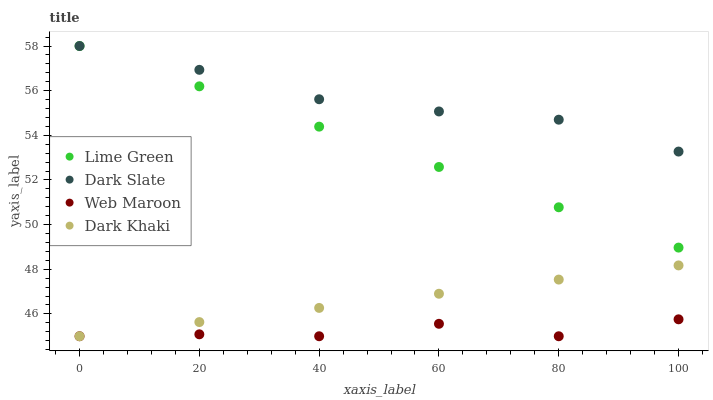Does Web Maroon have the minimum area under the curve?
Answer yes or no. Yes. Does Dark Slate have the maximum area under the curve?
Answer yes or no. Yes. Does Lime Green have the minimum area under the curve?
Answer yes or no. No. Does Lime Green have the maximum area under the curve?
Answer yes or no. No. Is Lime Green the smoothest?
Answer yes or no. Yes. Is Web Maroon the roughest?
Answer yes or no. Yes. Is Dark Slate the smoothest?
Answer yes or no. No. Is Dark Slate the roughest?
Answer yes or no. No. Does Dark Khaki have the lowest value?
Answer yes or no. Yes. Does Lime Green have the lowest value?
Answer yes or no. No. Does Lime Green have the highest value?
Answer yes or no. Yes. Does Web Maroon have the highest value?
Answer yes or no. No. Is Web Maroon less than Lime Green?
Answer yes or no. Yes. Is Dark Slate greater than Web Maroon?
Answer yes or no. Yes. Does Web Maroon intersect Dark Khaki?
Answer yes or no. Yes. Is Web Maroon less than Dark Khaki?
Answer yes or no. No. Is Web Maroon greater than Dark Khaki?
Answer yes or no. No. Does Web Maroon intersect Lime Green?
Answer yes or no. No. 